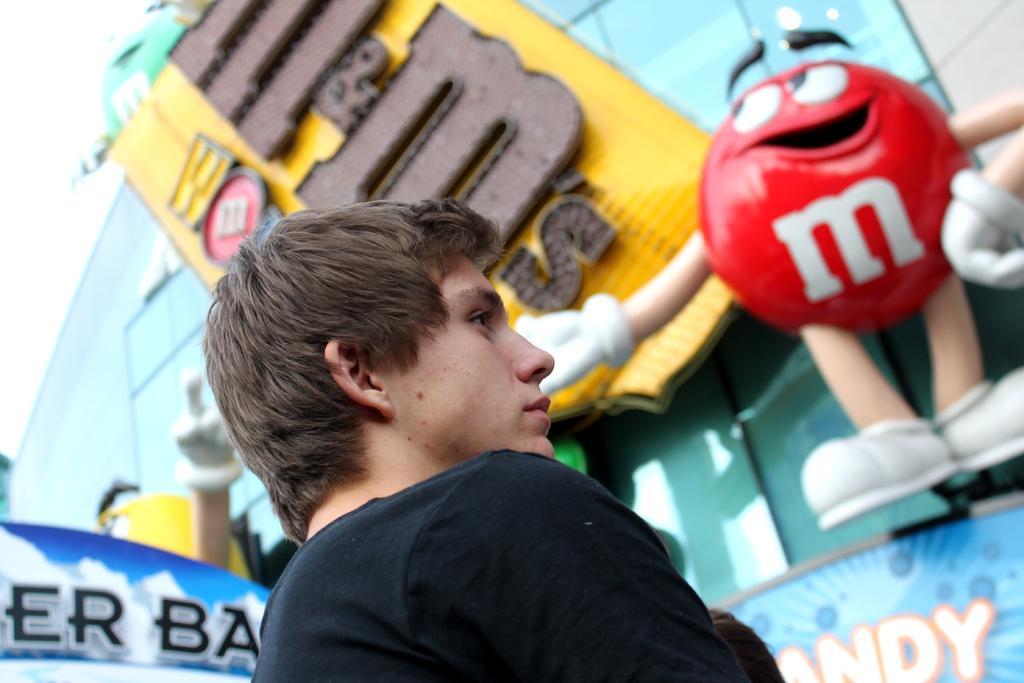How would you summarize this image in a sentence or two? In this image I can see a person wearing black dress. Back I can see a colorful board and red color toy. 